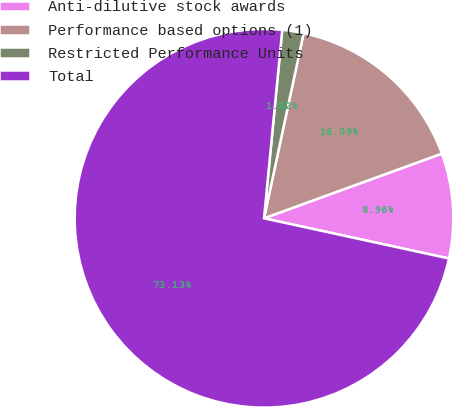Convert chart to OTSL. <chart><loc_0><loc_0><loc_500><loc_500><pie_chart><fcel>Anti-dilutive stock awards<fcel>Performance based options (1)<fcel>Restricted Performance Units<fcel>Total<nl><fcel>8.96%<fcel>16.09%<fcel>1.82%<fcel>73.13%<nl></chart> 